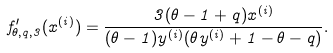<formula> <loc_0><loc_0><loc_500><loc_500>f ^ { \prime } _ { \theta , q , 3 } ( x ^ { ( i ) } ) = \frac { 3 ( \theta - 1 + q ) x ^ { ( i ) } } { ( \theta - 1 ) y ^ { ( i ) } ( \theta y ^ { ( i ) } + 1 - \theta - q ) } .</formula> 